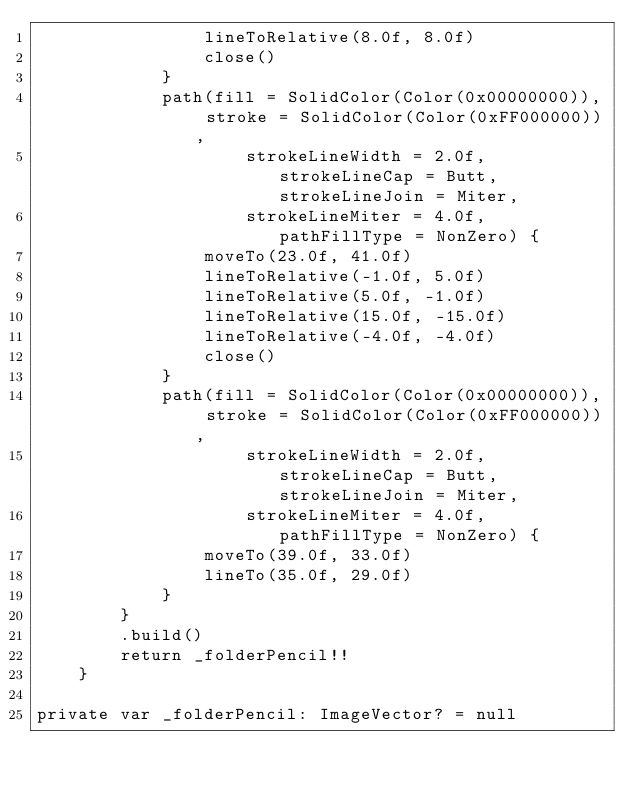Convert code to text. <code><loc_0><loc_0><loc_500><loc_500><_Kotlin_>                lineToRelative(8.0f, 8.0f)
                close()
            }
            path(fill = SolidColor(Color(0x00000000)), stroke = SolidColor(Color(0xFF000000)),
                    strokeLineWidth = 2.0f, strokeLineCap = Butt, strokeLineJoin = Miter,
                    strokeLineMiter = 4.0f, pathFillType = NonZero) {
                moveTo(23.0f, 41.0f)
                lineToRelative(-1.0f, 5.0f)
                lineToRelative(5.0f, -1.0f)
                lineToRelative(15.0f, -15.0f)
                lineToRelative(-4.0f, -4.0f)
                close()
            }
            path(fill = SolidColor(Color(0x00000000)), stroke = SolidColor(Color(0xFF000000)),
                    strokeLineWidth = 2.0f, strokeLineCap = Butt, strokeLineJoin = Miter,
                    strokeLineMiter = 4.0f, pathFillType = NonZero) {
                moveTo(39.0f, 33.0f)
                lineTo(35.0f, 29.0f)
            }
        }
        .build()
        return _folderPencil!!
    }

private var _folderPencil: ImageVector? = null
</code> 